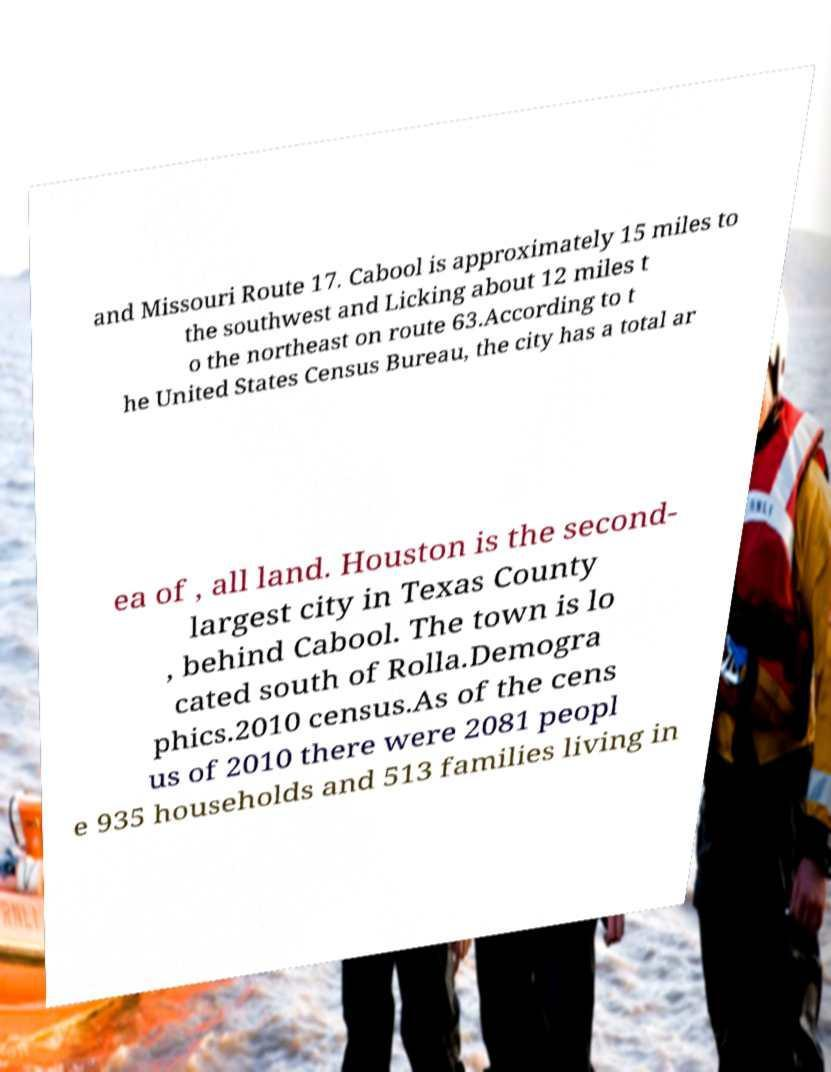Please read and relay the text visible in this image. What does it say? and Missouri Route 17. Cabool is approximately 15 miles to the southwest and Licking about 12 miles t o the northeast on route 63.According to t he United States Census Bureau, the city has a total ar ea of , all land. Houston is the second- largest city in Texas County , behind Cabool. The town is lo cated south of Rolla.Demogra phics.2010 census.As of the cens us of 2010 there were 2081 peopl e 935 households and 513 families living in 